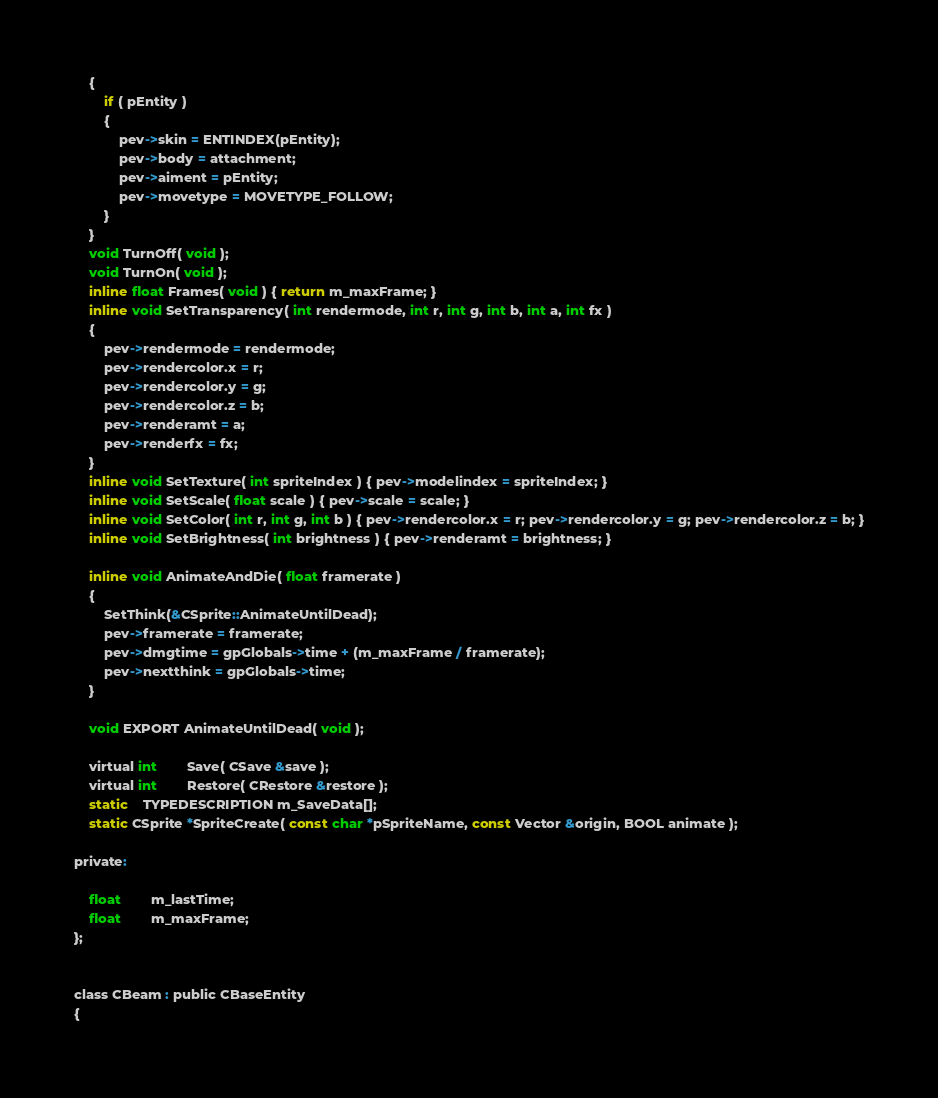Convert code to text. <code><loc_0><loc_0><loc_500><loc_500><_C_>	{
		if ( pEntity )
		{
			pev->skin = ENTINDEX(pEntity);
			pev->body = attachment;
			pev->aiment = pEntity;
			pev->movetype = MOVETYPE_FOLLOW;
		}
	}
	void TurnOff( void );
	void TurnOn( void );
	inline float Frames( void ) { return m_maxFrame; }
	inline void SetTransparency( int rendermode, int r, int g, int b, int a, int fx )
	{
		pev->rendermode = rendermode;
		pev->rendercolor.x = r;
		pev->rendercolor.y = g;
		pev->rendercolor.z = b;
		pev->renderamt = a;
		pev->renderfx = fx;
	}
	inline void SetTexture( int spriteIndex ) { pev->modelindex = spriteIndex; }
	inline void SetScale( float scale ) { pev->scale = scale; }
	inline void SetColor( int r, int g, int b ) { pev->rendercolor.x = r; pev->rendercolor.y = g; pev->rendercolor.z = b; }
	inline void SetBrightness( int brightness ) { pev->renderamt = brightness; }

	inline void AnimateAndDie( float framerate ) 
	{ 
		SetThink(&CSprite::AnimateUntilDead); 
		pev->framerate = framerate;
		pev->dmgtime = gpGlobals->time + (m_maxFrame / framerate); 
		pev->nextthink = gpGlobals->time; 
	}

	void EXPORT AnimateUntilDead( void );

	virtual int		Save( CSave &save );
	virtual int		Restore( CRestore &restore );
	static	TYPEDESCRIPTION m_SaveData[];
	static CSprite *SpriteCreate( const char *pSpriteName, const Vector &origin, BOOL animate );

private:

	float		m_lastTime;
	float		m_maxFrame;
};


class CBeam : public CBaseEntity
{</code> 